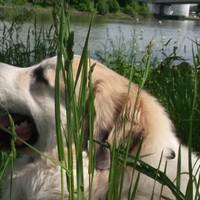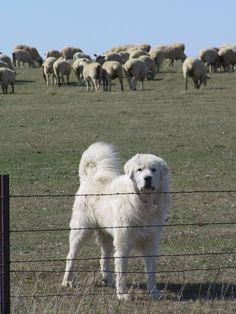The first image is the image on the left, the second image is the image on the right. For the images displayed, is the sentence "There are exactly two dogs in the image on the right." factually correct? Answer yes or no. No. The first image is the image on the left, the second image is the image on the right. Evaluate the accuracy of this statement regarding the images: "In one image, one dog is shown with a flock of goats.". Is it true? Answer yes or no. No. 